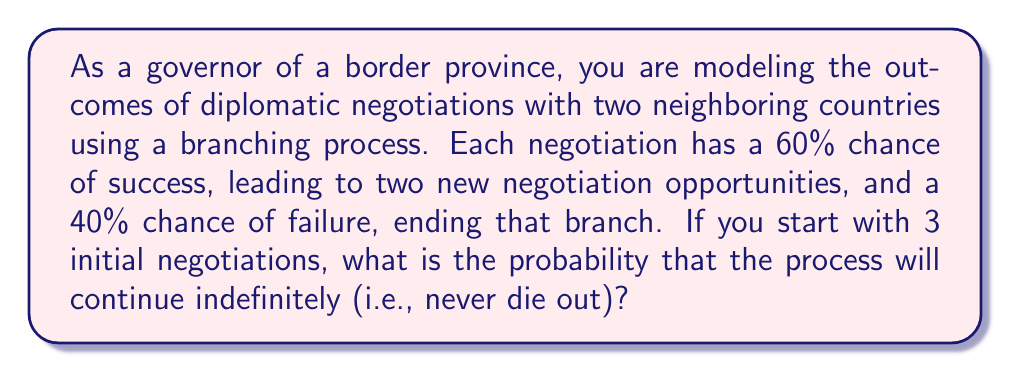Teach me how to tackle this problem. Let's approach this step-by-step:

1) In a branching process, we're interested in the extinction probability, which is the probability that the process will eventually die out. Let's call this probability $q$.

2) For the process to continue indefinitely, it must not go extinct. So, we're looking for $1-q$.

3) In this case, each successful negotiation (with probability 0.6) leads to 2 new negotiations. We can express this as a generating function:

   $f(s) = 0.4 + 0.6s^2$

4) The extinction probability $q$ is the smallest non-negative root of the equation:

   $s = f(s) = 0.4 + 0.6s^2$

5) Rearranging this equation:

   $0.6s^2 - s + 0.4 = 0$

6) We can solve this quadratic equation:

   $s = \frac{1 \pm \sqrt{1 - 4(0.6)(0.4)}}{2(0.6)} = \frac{1 \pm \sqrt{0.04}}{1.2} = \frac{1 \pm 0.2}{1.2}$

7) This gives us two solutions: $s = 1$ or $s = \frac{2}{3}$

8) The smaller solution is $q = \frac{2}{3}$

9) For a single negotiation, the probability of not going extinct is $1-q = \frac{1}{3}$

10) However, we start with 3 independent negotiations. The probability that at least one of these continues indefinitely is:

    $1 - (\frac{2}{3})^3 = 1 - \frac{8}{27} = \frac{19}{27}$

Therefore, the probability that the process will continue indefinitely is $\frac{19}{27}$.
Answer: $\frac{19}{27}$ 